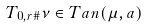Convert formula to latex. <formula><loc_0><loc_0><loc_500><loc_500>T _ { 0 , r \# } \nu \in T a n ( \mu , a )</formula> 